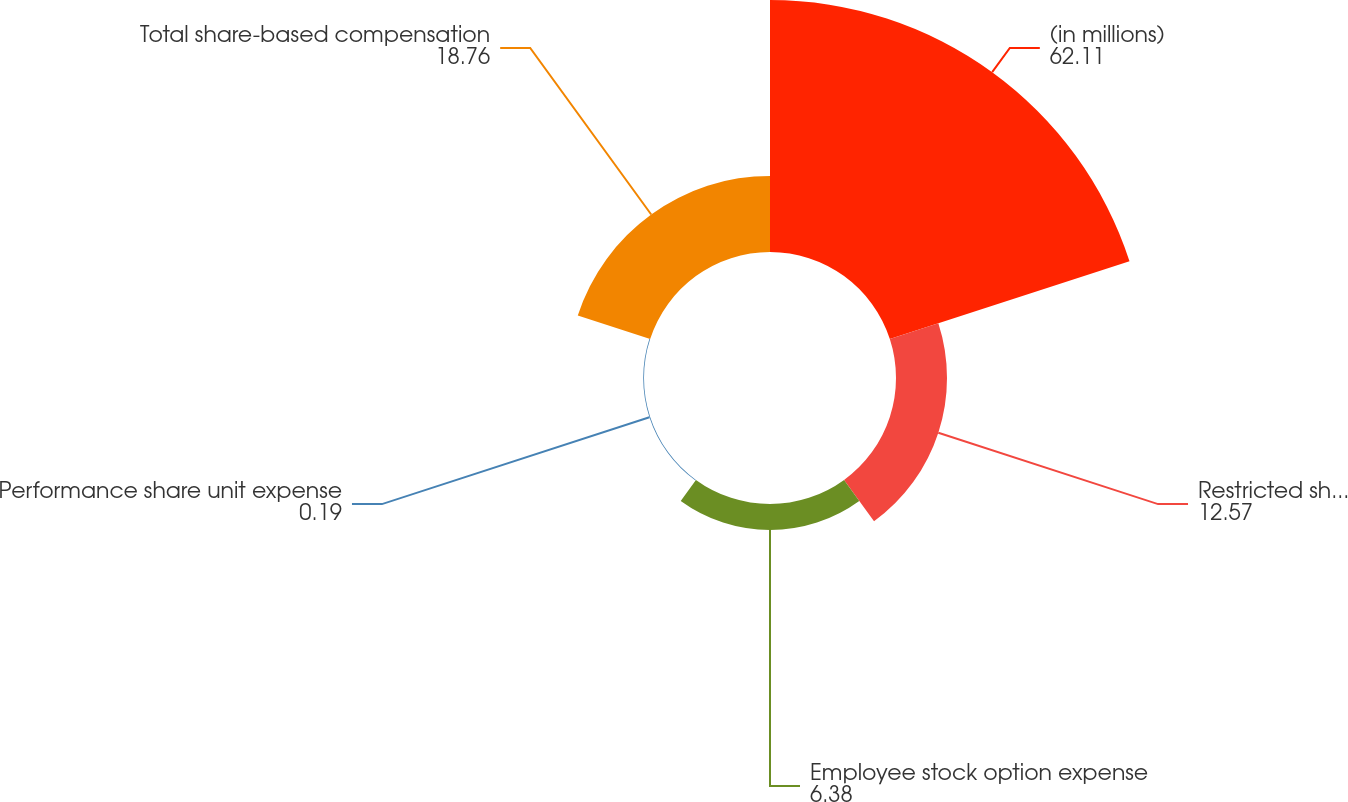Convert chart to OTSL. <chart><loc_0><loc_0><loc_500><loc_500><pie_chart><fcel>(in millions)<fcel>Restricted shares and share<fcel>Employee stock option expense<fcel>Performance share unit expense<fcel>Total share-based compensation<nl><fcel>62.11%<fcel>12.57%<fcel>6.38%<fcel>0.19%<fcel>18.76%<nl></chart> 